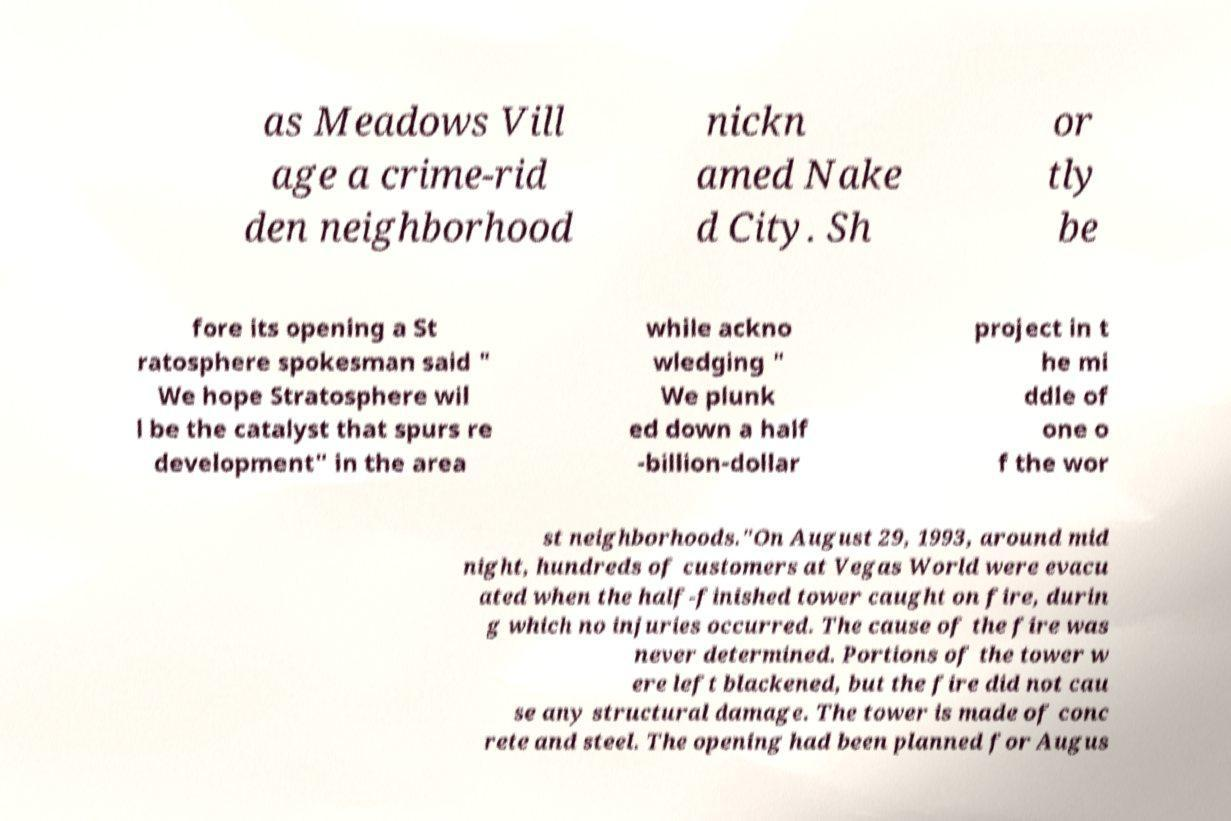Can you read and provide the text displayed in the image?This photo seems to have some interesting text. Can you extract and type it out for me? as Meadows Vill age a crime-rid den neighborhood nickn amed Nake d City. Sh or tly be fore its opening a St ratosphere spokesman said " We hope Stratosphere wil l be the catalyst that spurs re development" in the area while ackno wledging " We plunk ed down a half -billion-dollar project in t he mi ddle of one o f the wor st neighborhoods."On August 29, 1993, around mid night, hundreds of customers at Vegas World were evacu ated when the half-finished tower caught on fire, durin g which no injuries occurred. The cause of the fire was never determined. Portions of the tower w ere left blackened, but the fire did not cau se any structural damage. The tower is made of conc rete and steel. The opening had been planned for Augus 